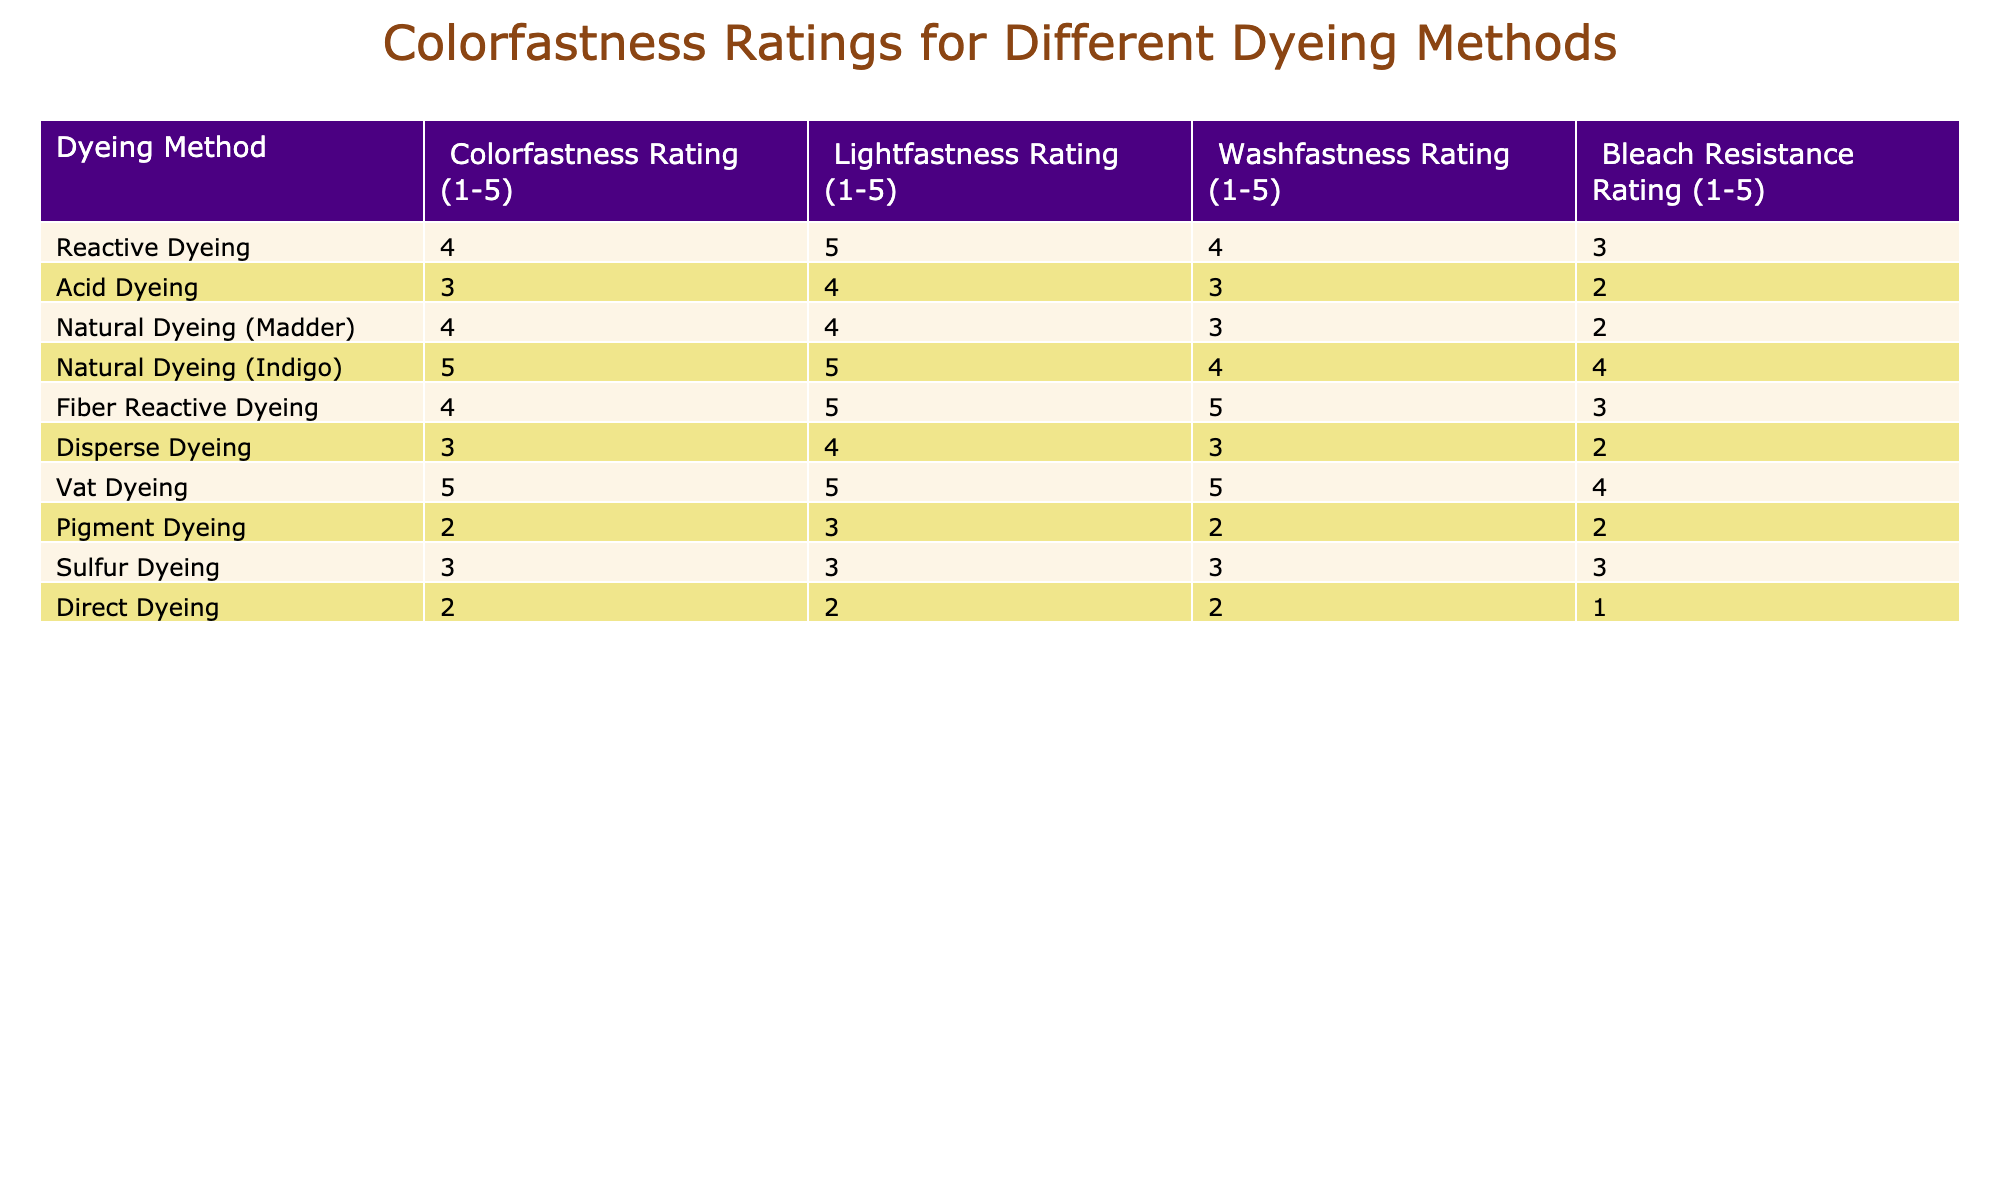What is the highest colorfastness rating among the dyeing methods? Looking at the "Colorfastness Rating" column, the value '5' appears for the dyeing methods "Natural Dyeing (Indigo)" and "Vat Dyeing." Therefore, the highest colorfastness rating is 5.
Answer: 5 Which dyeing method has the lowest washfastness rating? In the "Washfastness Rating" column, the lowest value present is '1' corresponding to the "Direct Dyeing" method.
Answer: Direct Dyeing Is the bleach resistance rating for Reactive Dyeing higher than that for Acid Dyeing? The bleach resistance rating for Reactive Dyeing is '3', while Acid Dyeing has a rating of '2'. Since '3' is greater than '2', the statement is true.
Answer: Yes What is the average lightfastness rating for methods using natural dyes? The methods for natural dyes are "Natural Dyeing (Madder)" and "Natural Dyeing (Indigo)." Their respective lightfastness ratings are 4 and 5. The average is (4 + 5) / 2 = 4.5.
Answer: 4.5 Which dyeing method has the highest ratings in both lightfastness and colorfastness? The method "Natural Dyeing (Indigo)" has a colorfastness rating of 5 and a lightfastness rating of 5, making it the highest for both categories.
Answer: Natural Dyeing (Indigo) How many dyeing methods have a washfastness rating of 4 or higher? The methods with a washfastness rating of 4 or higher are "Reactive Dyeing," "Fiber Reactive Dyeing," and "Vat Dyeing," totaling 3 methods.
Answer: 3 Is it true that Pigment Dyeing has a colorfastness rating equal to that of Sulfur Dyeing? Looking at the "Colorfastness Rating," Pigment Dyeing has a rating of '2', while Sulfur Dyeing also has a rating of '3'. Therefore, the statement is false.
Answer: No Which dyeing method is the best overall based on all ratings? To assess the best overall, we determine the average across all ratings for each dyeing method. "Vat Dyeing" has an average of (5 + 5 + 5 + 4) = 19 / 4 = 4.75, which is the highest among all methods.
Answer: Vat Dyeing What is the difference in bleach resistance between Vat Dyeing and Pigment Dyeing? The bleach resistance for Vat Dyeing is '4' while for Pigment Dyeing it is '2'. The difference is 4 - 2 = 2.
Answer: 2 